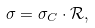<formula> <loc_0><loc_0><loc_500><loc_500>\sigma = \sigma _ { C } \cdot \mathcal { R } ,</formula> 